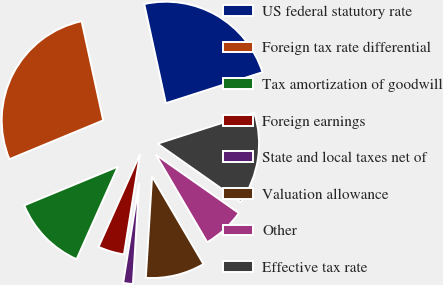<chart> <loc_0><loc_0><loc_500><loc_500><pie_chart><fcel>US federal statutory rate<fcel>Foreign tax rate differential<fcel>Tax amortization of goodwill<fcel>Foreign earnings<fcel>State and local taxes net of<fcel>Valuation allowance<fcel>Other<fcel>Effective tax rate<nl><fcel>23.47%<fcel>27.83%<fcel>12.06%<fcel>4.17%<fcel>1.54%<fcel>9.43%<fcel>6.8%<fcel>14.69%<nl></chart> 